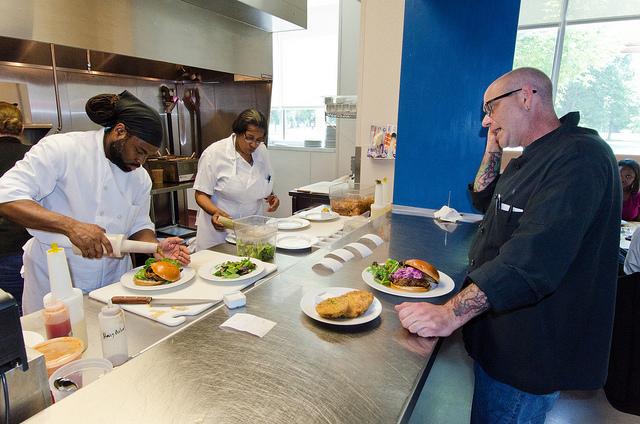Is the man waiting for more food?
Be succinct. Yes. Is this a restaurant?
Short answer required. Yes. Why is the man wearing a head covering?
Short answer required. Chef. What type of food do you think the chef is making?
Write a very short answer. Burgers. Does the man like his meal?
Write a very short answer. Yes. 